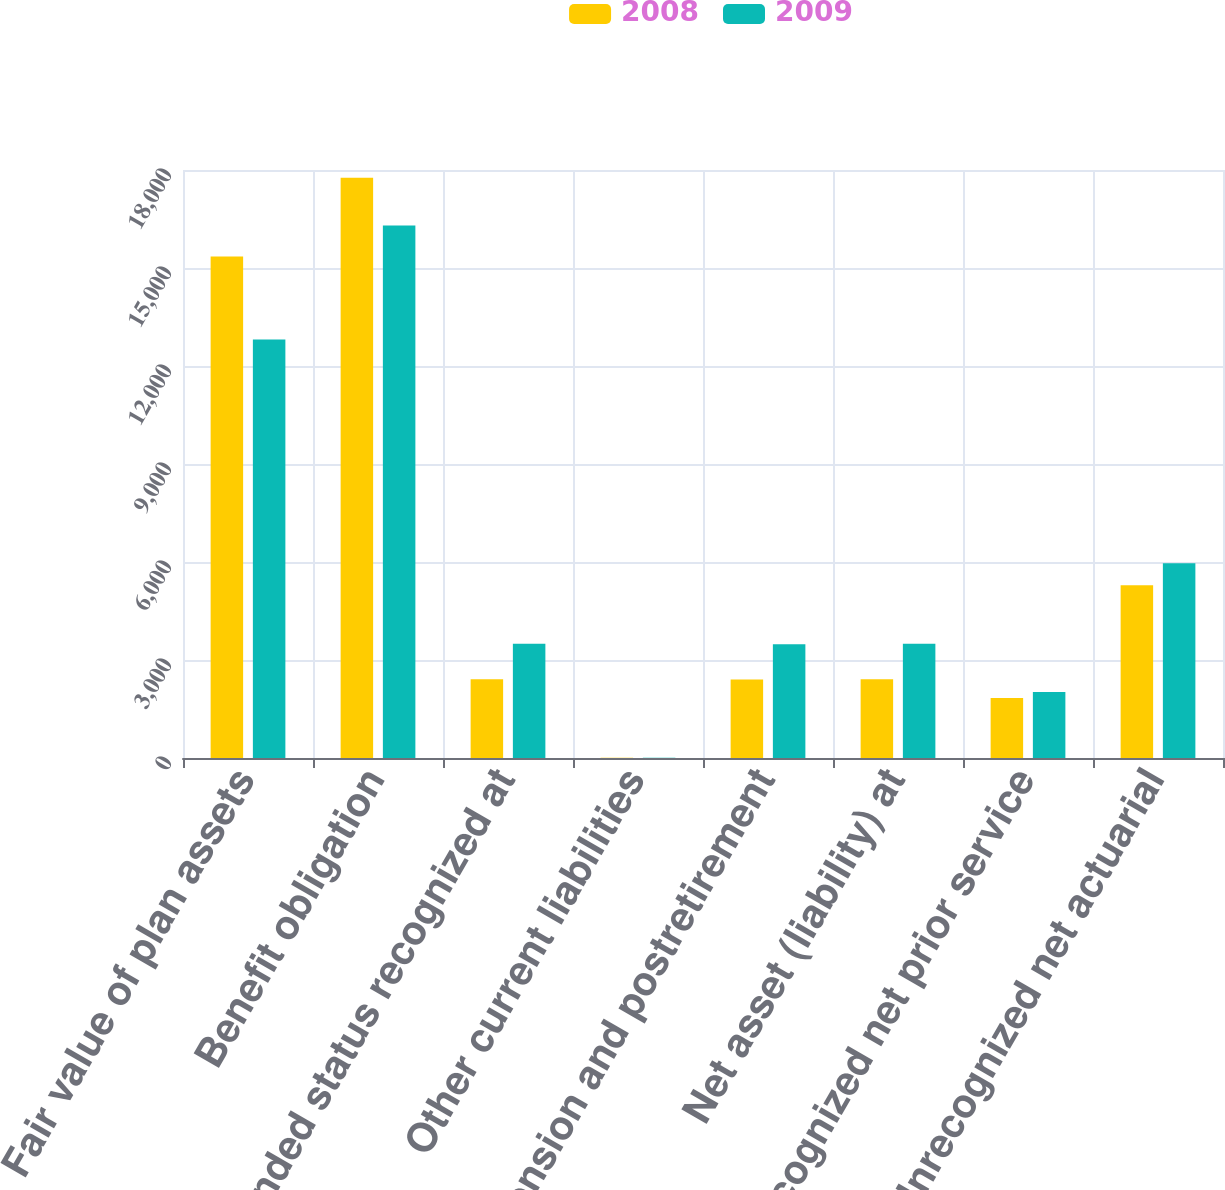<chart> <loc_0><loc_0><loc_500><loc_500><stacked_bar_chart><ecel><fcel>Fair value of plan assets<fcel>Benefit obligation<fcel>Funded status recognized at<fcel>Other current liabilities<fcel>Pension and postretirement<fcel>Net asset (liability) at<fcel>Unrecognized net prior service<fcel>Unrecognized net actuarial<nl><fcel>2008<fcel>15351<fcel>17763<fcel>2412<fcel>11<fcel>2401<fcel>2412<fcel>1839<fcel>5289<nl><fcel>2009<fcel>12809<fcel>16303<fcel>3494<fcel>10<fcel>3484<fcel>3494<fcel>2017<fcel>5963<nl></chart> 